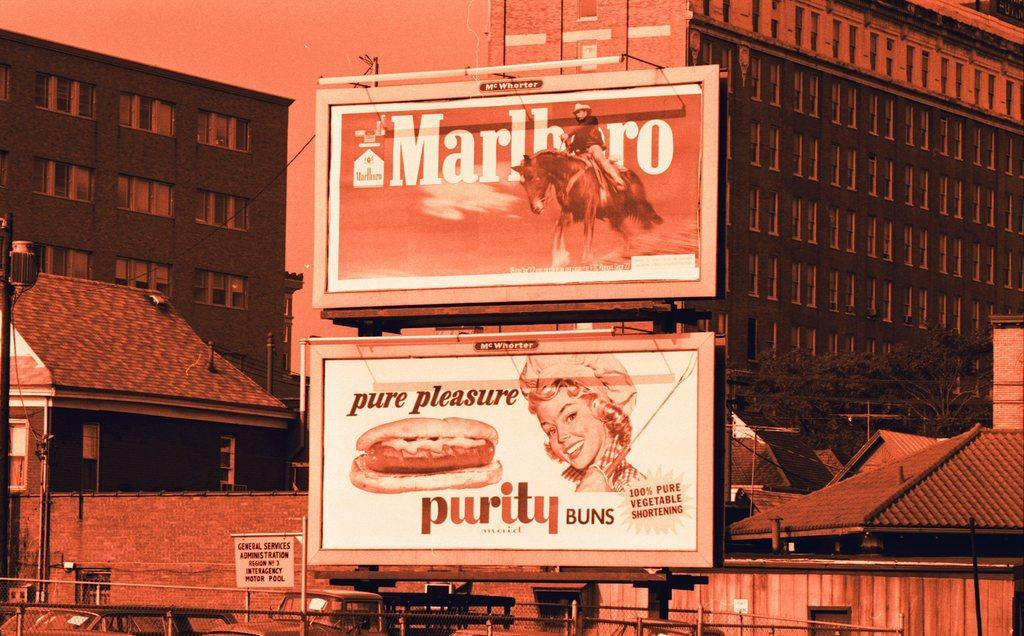In one or two sentences, can you explain what this image depicts? In this image we can see many buildings. And we can see the windows. And we can see a few houses. And we can see the two hoardings. And we can see the vehicles. And we can see the metal fencing. 